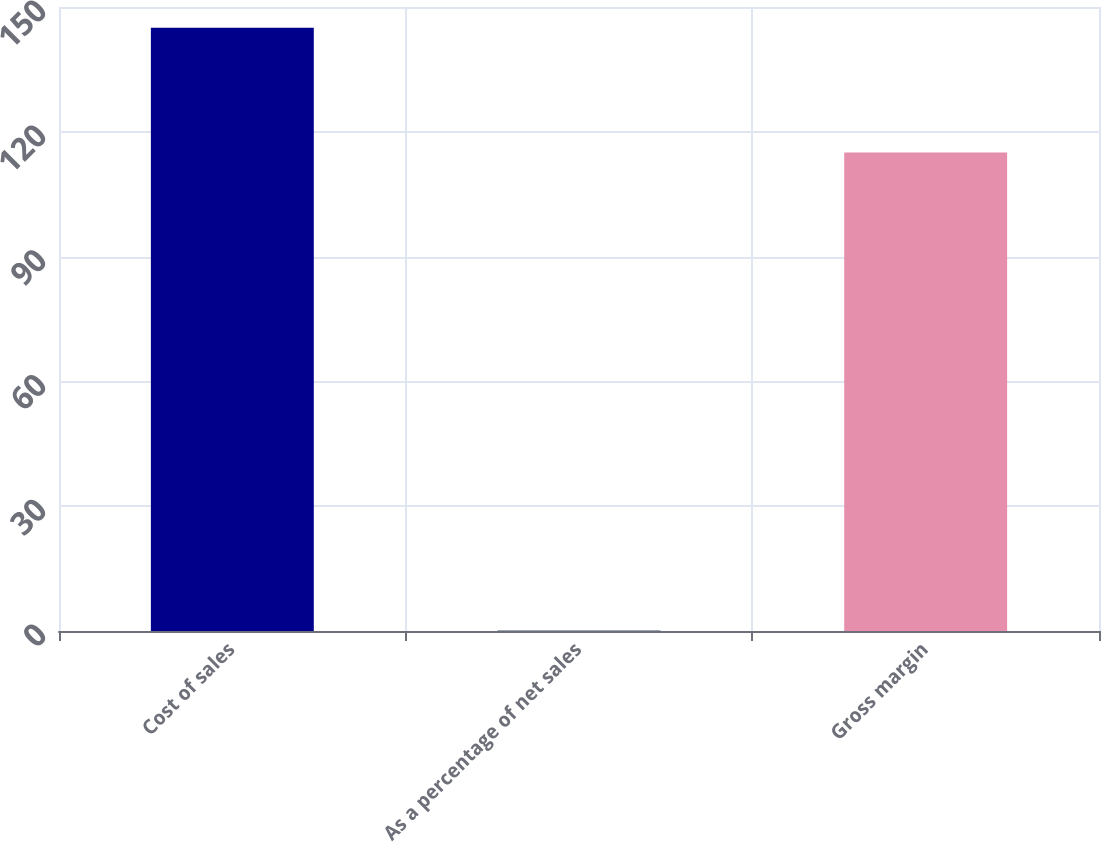Convert chart to OTSL. <chart><loc_0><loc_0><loc_500><loc_500><bar_chart><fcel>Cost of sales<fcel>As a percentage of net sales<fcel>Gross margin<nl><fcel>145<fcel>0.2<fcel>115<nl></chart> 